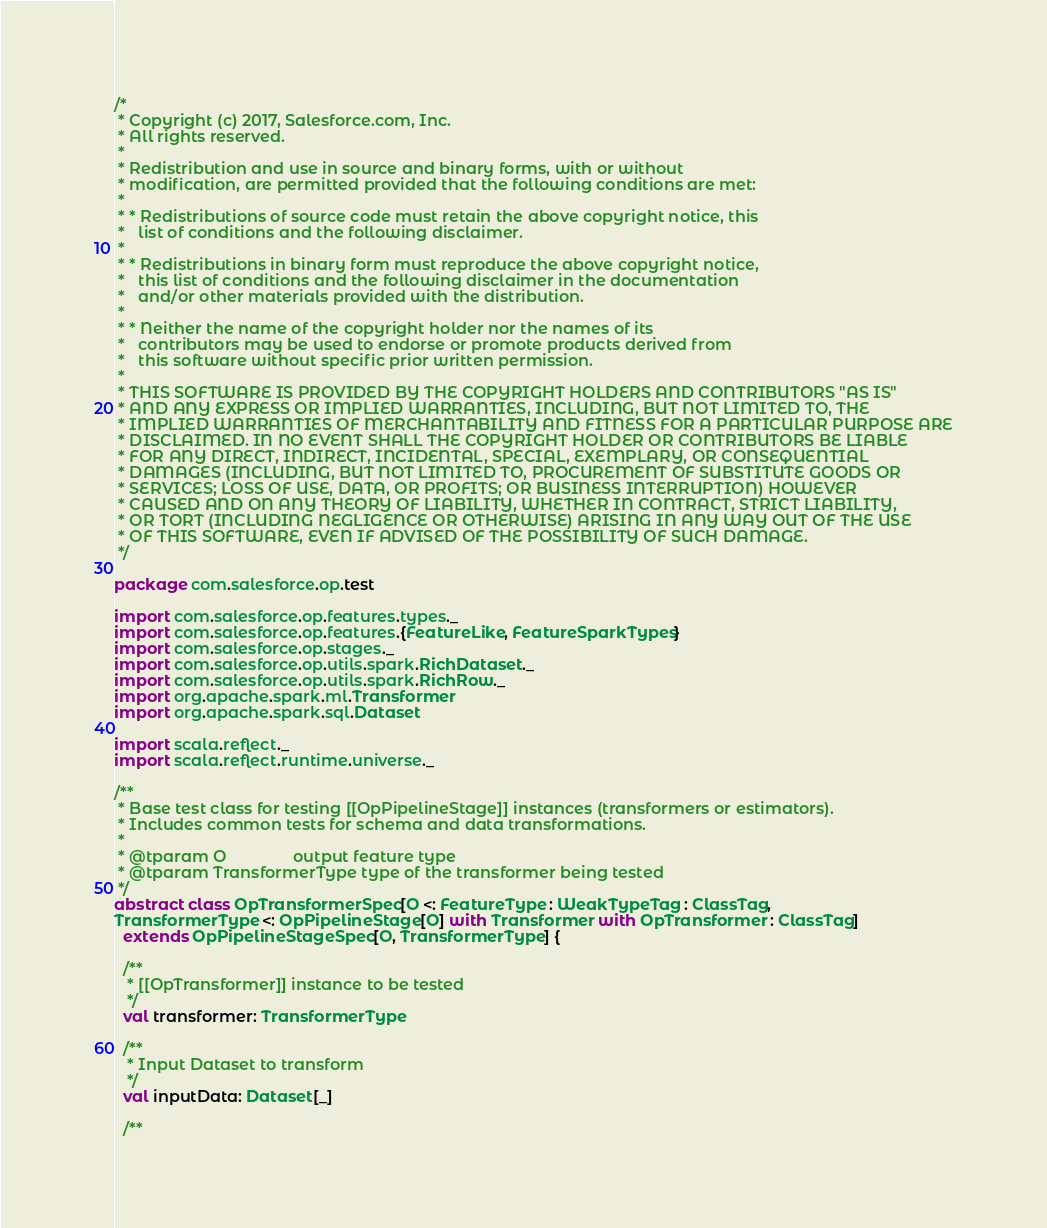<code> <loc_0><loc_0><loc_500><loc_500><_Scala_>/*
 * Copyright (c) 2017, Salesforce.com, Inc.
 * All rights reserved.
 *
 * Redistribution and use in source and binary forms, with or without
 * modification, are permitted provided that the following conditions are met:
 *
 * * Redistributions of source code must retain the above copyright notice, this
 *   list of conditions and the following disclaimer.
 *
 * * Redistributions in binary form must reproduce the above copyright notice,
 *   this list of conditions and the following disclaimer in the documentation
 *   and/or other materials provided with the distribution.
 *
 * * Neither the name of the copyright holder nor the names of its
 *   contributors may be used to endorse or promote products derived from
 *   this software without specific prior written permission.
 *
 * THIS SOFTWARE IS PROVIDED BY THE COPYRIGHT HOLDERS AND CONTRIBUTORS "AS IS"
 * AND ANY EXPRESS OR IMPLIED WARRANTIES, INCLUDING, BUT NOT LIMITED TO, THE
 * IMPLIED WARRANTIES OF MERCHANTABILITY AND FITNESS FOR A PARTICULAR PURPOSE ARE
 * DISCLAIMED. IN NO EVENT SHALL THE COPYRIGHT HOLDER OR CONTRIBUTORS BE LIABLE
 * FOR ANY DIRECT, INDIRECT, INCIDENTAL, SPECIAL, EXEMPLARY, OR CONSEQUENTIAL
 * DAMAGES (INCLUDING, BUT NOT LIMITED TO, PROCUREMENT OF SUBSTITUTE GOODS OR
 * SERVICES; LOSS OF USE, DATA, OR PROFITS; OR BUSINESS INTERRUPTION) HOWEVER
 * CAUSED AND ON ANY THEORY OF LIABILITY, WHETHER IN CONTRACT, STRICT LIABILITY,
 * OR TORT (INCLUDING NEGLIGENCE OR OTHERWISE) ARISING IN ANY WAY OUT OF THE USE
 * OF THIS SOFTWARE, EVEN IF ADVISED OF THE POSSIBILITY OF SUCH DAMAGE.
 */

package com.salesforce.op.test

import com.salesforce.op.features.types._
import com.salesforce.op.features.{FeatureLike, FeatureSparkTypes}
import com.salesforce.op.stages._
import com.salesforce.op.utils.spark.RichDataset._
import com.salesforce.op.utils.spark.RichRow._
import org.apache.spark.ml.Transformer
import org.apache.spark.sql.Dataset

import scala.reflect._
import scala.reflect.runtime.universe._

/**
 * Base test class for testing [[OpPipelineStage]] instances (transformers or estimators).
 * Includes common tests for schema and data transformations.
 *
 * @tparam O               output feature type
 * @tparam TransformerType type of the transformer being tested
 */
abstract class OpTransformerSpec[O <: FeatureType : WeakTypeTag : ClassTag,
TransformerType <: OpPipelineStage[O] with Transformer with OpTransformer : ClassTag]
  extends OpPipelineStageSpec[O, TransformerType] {

  /**
   * [[OpTransformer]] instance to be tested
   */
  val transformer: TransformerType

  /**
   * Input Dataset to transform
   */
  val inputData: Dataset[_]

  /**</code> 